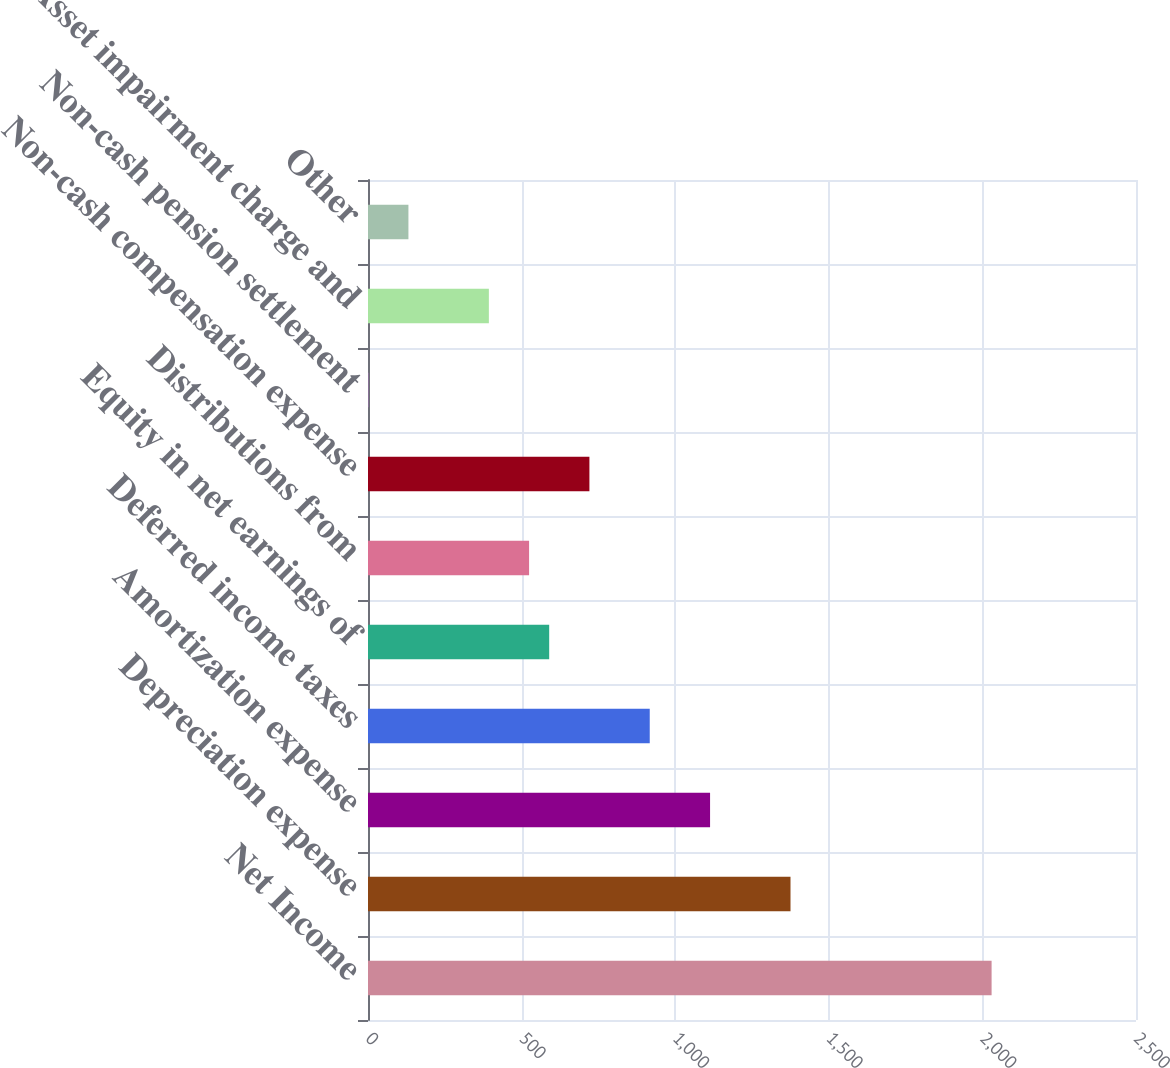<chart> <loc_0><loc_0><loc_500><loc_500><bar_chart><fcel>Net Income<fcel>Depreciation expense<fcel>Amortization expense<fcel>Deferred income taxes<fcel>Equity in net earnings of<fcel>Distributions from<fcel>Non-cash compensation expense<fcel>Non-cash pension settlement<fcel>Asset impairment charge and<fcel>Other<nl><fcel>2029.94<fcel>1375.34<fcel>1113.5<fcel>917.12<fcel>589.82<fcel>524.36<fcel>720.74<fcel>0.68<fcel>393.44<fcel>131.6<nl></chart> 